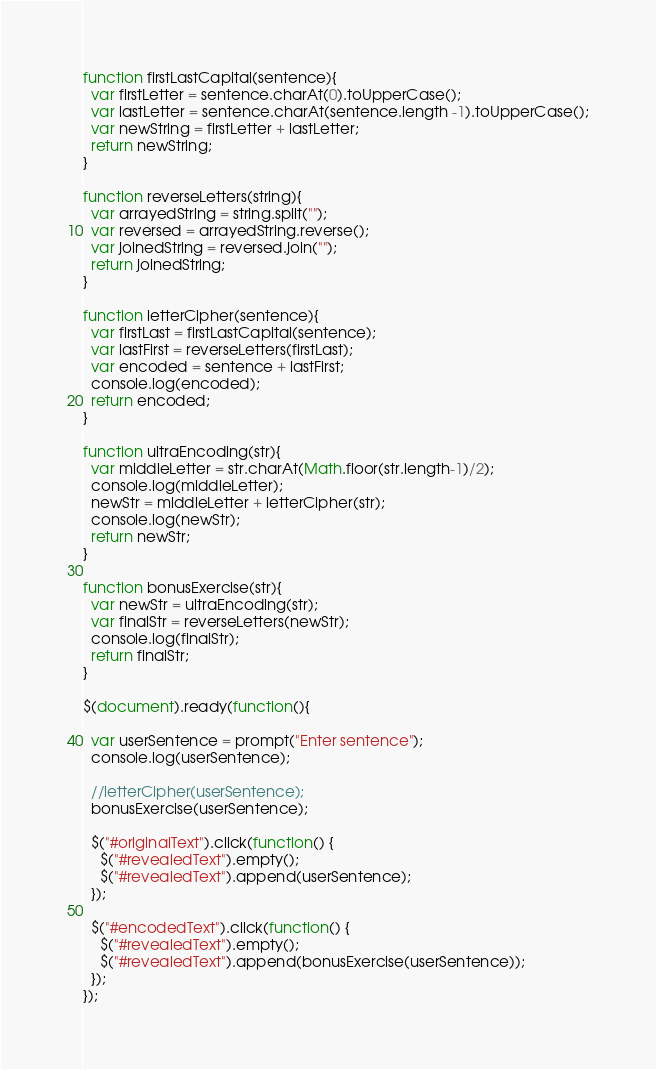<code> <loc_0><loc_0><loc_500><loc_500><_JavaScript_>function firstLastCapital(sentence){
  var firstLetter = sentence.charAt(0).toUpperCase();
  var lastLetter = sentence.charAt(sentence.length -1).toUpperCase();
  var newString = firstLetter + lastLetter;
  return newString;
}

function reverseLetters(string){
  var arrayedString = string.split("");
  var reversed = arrayedString.reverse();
  var joinedString = reversed.join("");
  return joinedString;
}

function letterCipher(sentence){
  var firstLast = firstLastCapital(sentence);
  var lastFirst = reverseLetters(firstLast);
  var encoded = sentence + lastFirst;
  console.log(encoded);
  return encoded;
}

function ultraEncoding(str){
  var middleLetter = str.charAt(Math.floor(str.length-1)/2);
  console.log(middleLetter);
  newStr = middleLetter + letterCipher(str);
  console.log(newStr);
  return newStr;
}

function bonusExercise(str){
  var newStr = ultraEncoding(str);
  var finalStr = reverseLetters(newStr);
  console.log(finalStr);
  return finalStr;
}

$(document).ready(function(){

  var userSentence = prompt("Enter sentence");
  console.log(userSentence);

  //letterCipher(userSentence);  
  bonusExercise(userSentence);

  $("#originalText").click(function() {
    $("#revealedText").empty();
    $("#revealedText").append(userSentence);
  });

  $("#encodedText").click(function() {
    $("#revealedText").empty();
    $("#revealedText").append(bonusExercise(userSentence));
  });
});</code> 